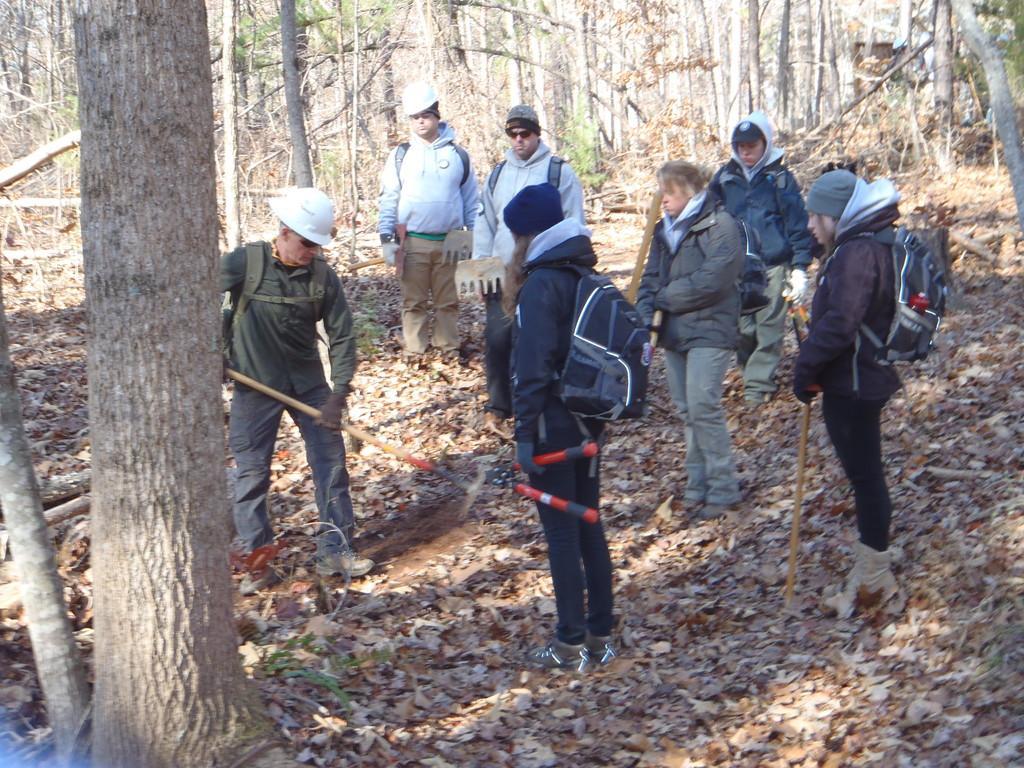Could you give a brief overview of what you see in this image? There are many people. Some are wearing bags, caps and jackets. Also they are holding some tools. On the ground there are dried leaves. Also there are many trees. 